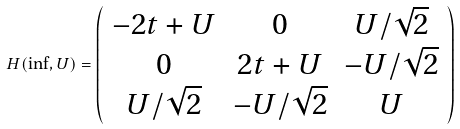Convert formula to latex. <formula><loc_0><loc_0><loc_500><loc_500>H ( \inf , U ) = \left ( \begin{array} { c c c } - 2 t + U & 0 & U / \sqrt { 2 } \\ 0 & 2 t + U & - U / \sqrt { 2 } \\ U / \sqrt { 2 } & - U / \sqrt { 2 } & U \end{array} \right )</formula> 